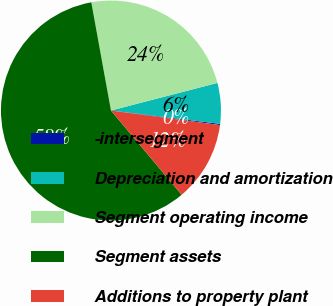Convert chart to OTSL. <chart><loc_0><loc_0><loc_500><loc_500><pie_chart><fcel>-intersegment<fcel>Depreciation and amortization<fcel>Segment operating income<fcel>Segment assets<fcel>Additions to property plant<nl><fcel>0.17%<fcel>5.98%<fcel>23.82%<fcel>58.25%<fcel>11.78%<nl></chart> 